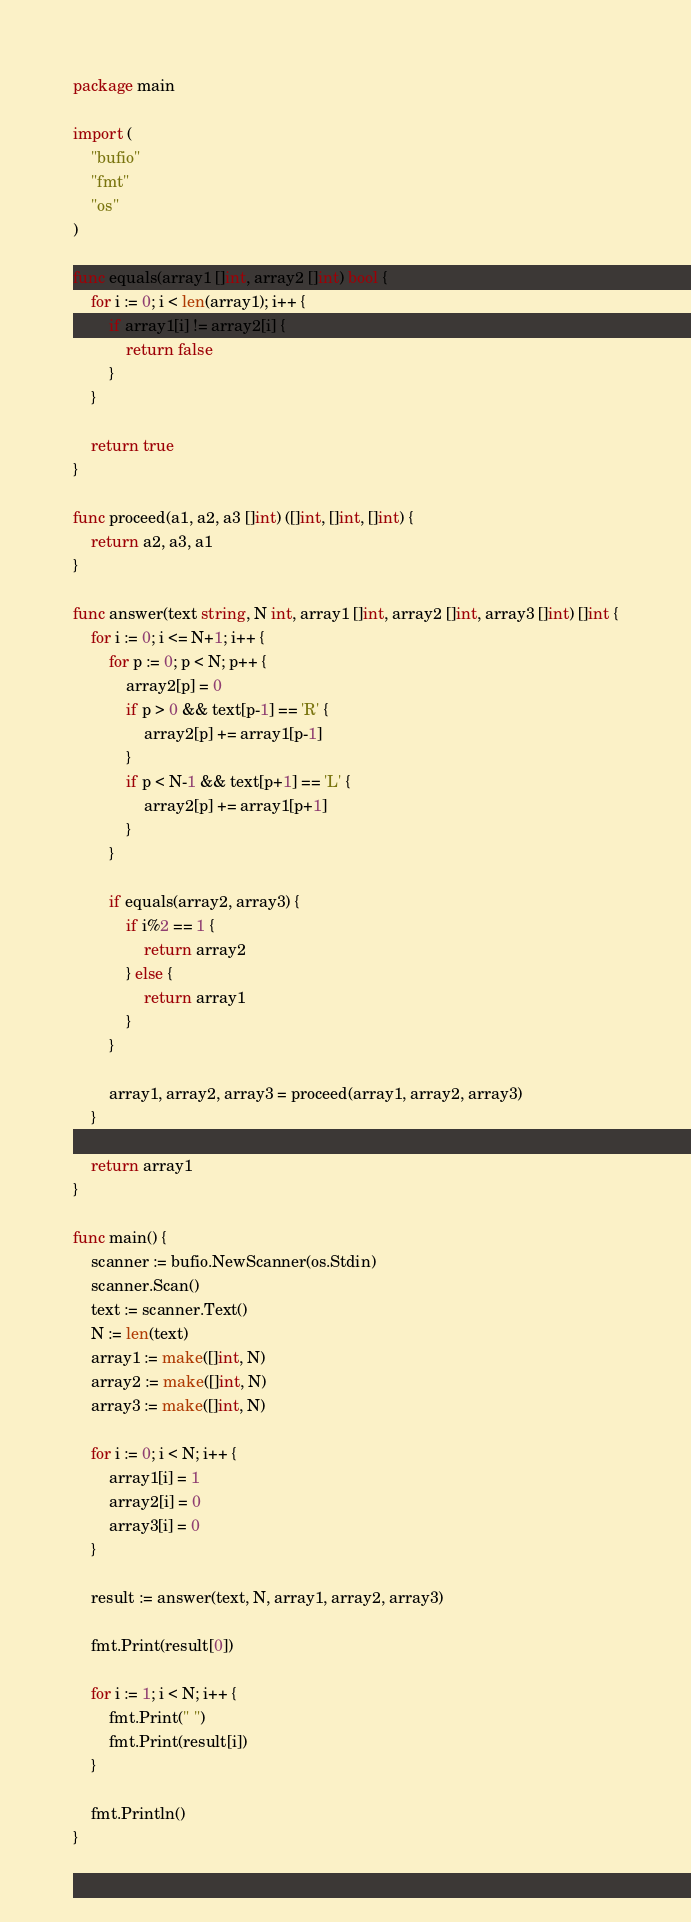Convert code to text. <code><loc_0><loc_0><loc_500><loc_500><_Go_>package main

import (
	"bufio"
	"fmt"
	"os"
)

func equals(array1 []int, array2 []int) bool {
	for i := 0; i < len(array1); i++ {
		if array1[i] != array2[i] {
			return false
		}
	}

	return true
}

func proceed(a1, a2, a3 []int) ([]int, []int, []int) {
	return a2, a3, a1
}

func answer(text string, N int, array1 []int, array2 []int, array3 []int) []int {
	for i := 0; i <= N+1; i++ {
		for p := 0; p < N; p++ {
			array2[p] = 0
			if p > 0 && text[p-1] == 'R' {
				array2[p] += array1[p-1]
			}
			if p < N-1 && text[p+1] == 'L' {
				array2[p] += array1[p+1]
			}
		}

		if equals(array2, array3) {
			if i%2 == 1 {
				return array2
			} else {
				return array1
			}
		}

		array1, array2, array3 = proceed(array1, array2, array3)
	}

	return array1
}

func main() {
	scanner := bufio.NewScanner(os.Stdin)
	scanner.Scan()
	text := scanner.Text()
	N := len(text)
	array1 := make([]int, N)
	array2 := make([]int, N)
	array3 := make([]int, N)

	for i := 0; i < N; i++ {
		array1[i] = 1
		array2[i] = 0
		array3[i] = 0
	}

	result := answer(text, N, array1, array2, array3)

	fmt.Print(result[0])

	for i := 1; i < N; i++ {
		fmt.Print(" ")
		fmt.Print(result[i])
	}

	fmt.Println()
}
</code> 